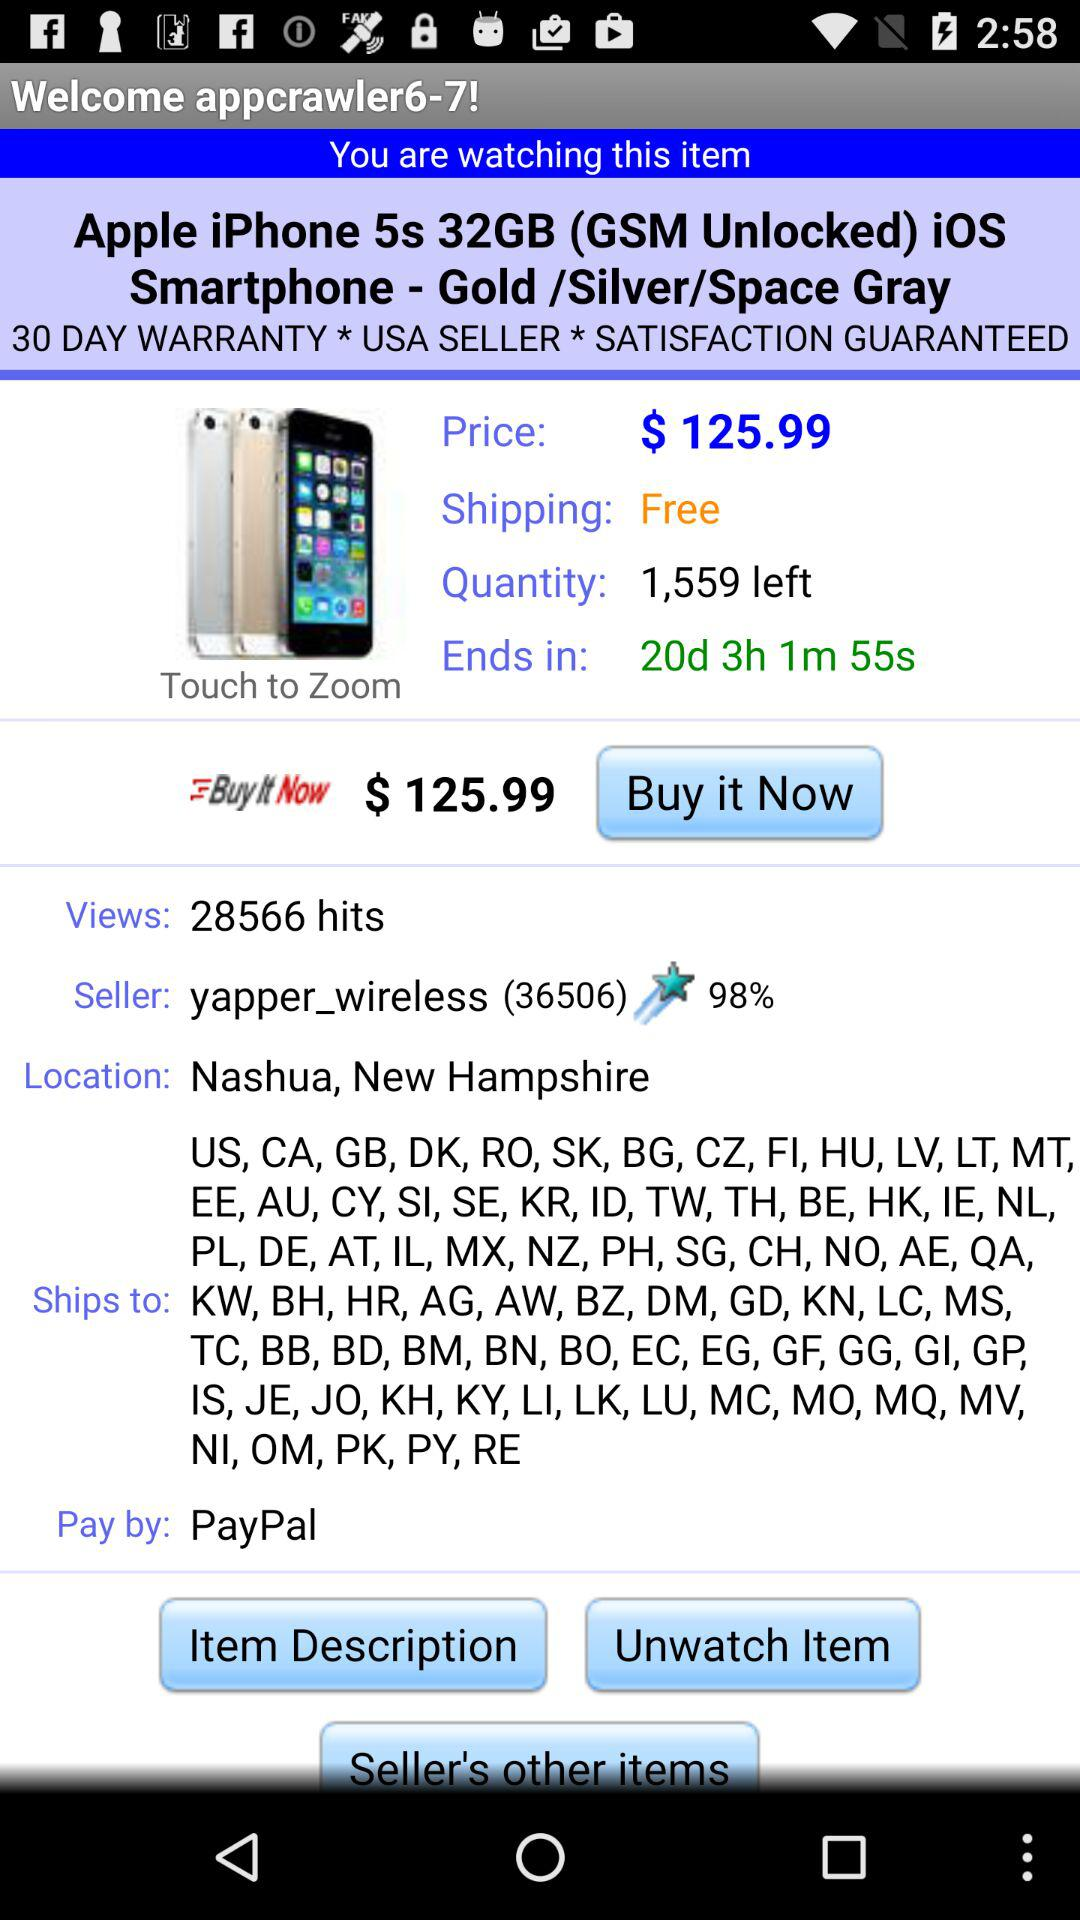What is the price? The price is $125.99. 